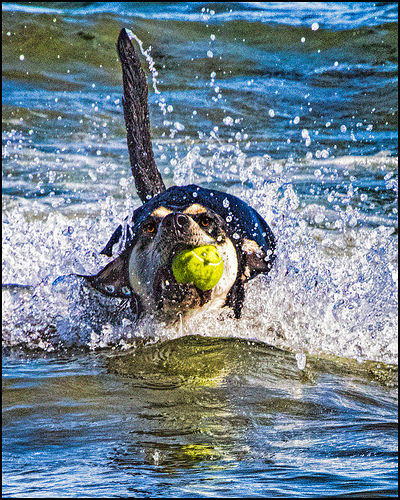<image>
Is there a water under the dog? Yes. The water is positioned underneath the dog, with the dog above it in the vertical space. Is there a ball in the water? No. The ball is not contained within the water. These objects have a different spatial relationship. 